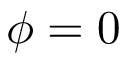Convert formula to latex. <formula><loc_0><loc_0><loc_500><loc_500>\phi = 0</formula> 